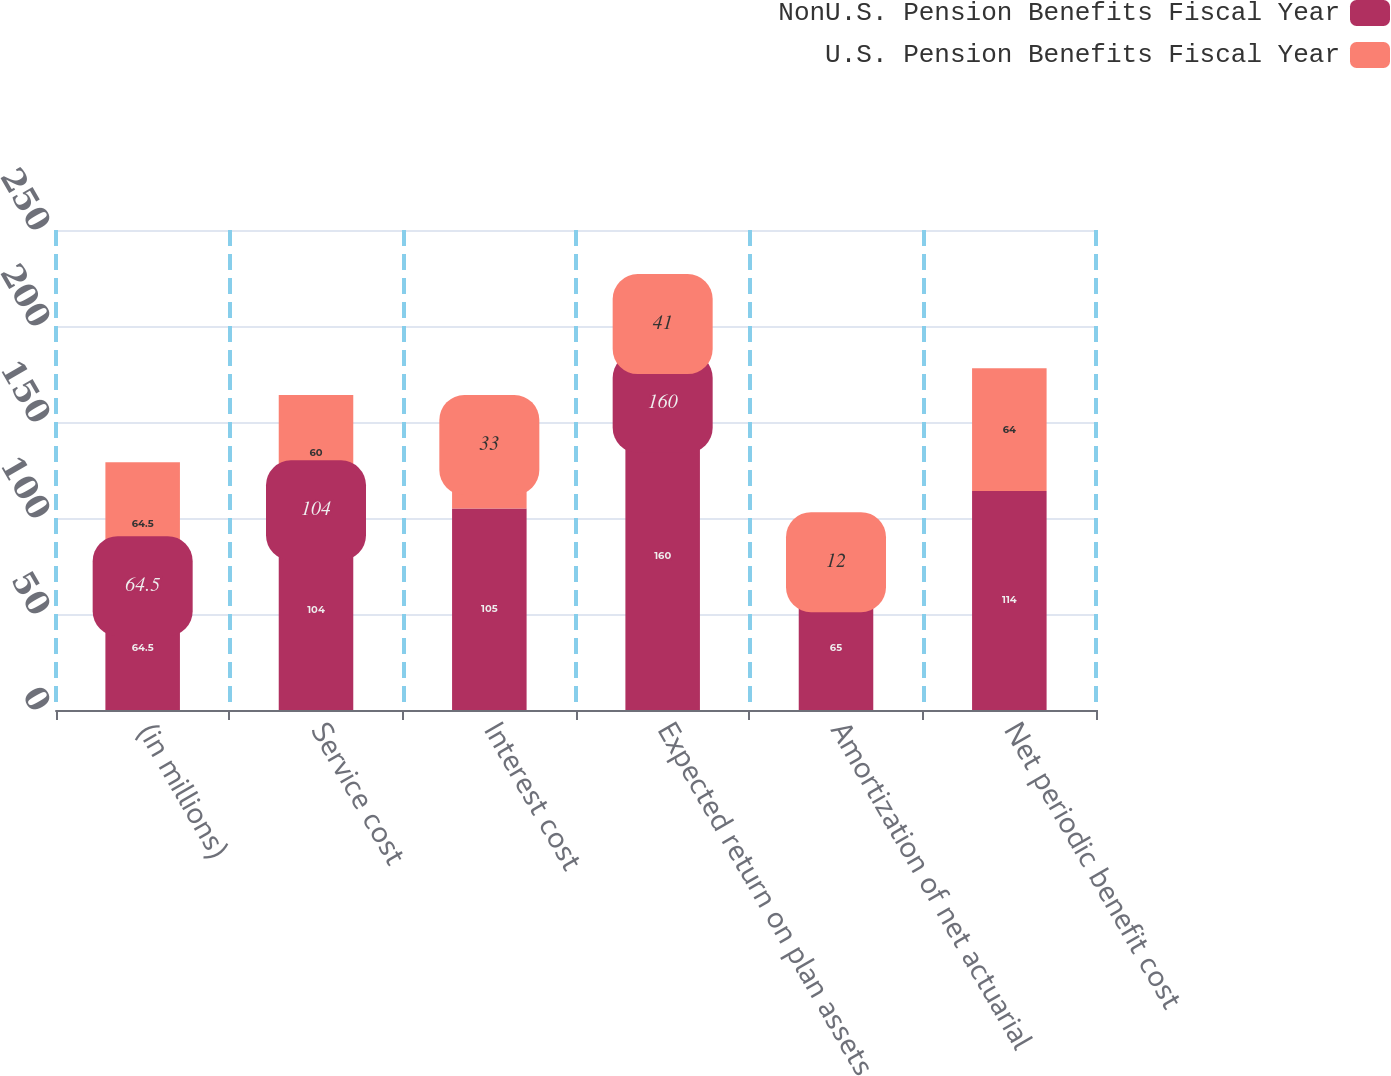Convert chart to OTSL. <chart><loc_0><loc_0><loc_500><loc_500><stacked_bar_chart><ecel><fcel>(in millions)<fcel>Service cost<fcel>Interest cost<fcel>Expected return on plan assets<fcel>Amortization of net actuarial<fcel>Net periodic benefit cost<nl><fcel>NonU.S. Pension Benefits Fiscal Year<fcel>64.5<fcel>104<fcel>105<fcel>160<fcel>65<fcel>114<nl><fcel>U.S. Pension Benefits Fiscal Year<fcel>64.5<fcel>60<fcel>33<fcel>41<fcel>12<fcel>64<nl></chart> 